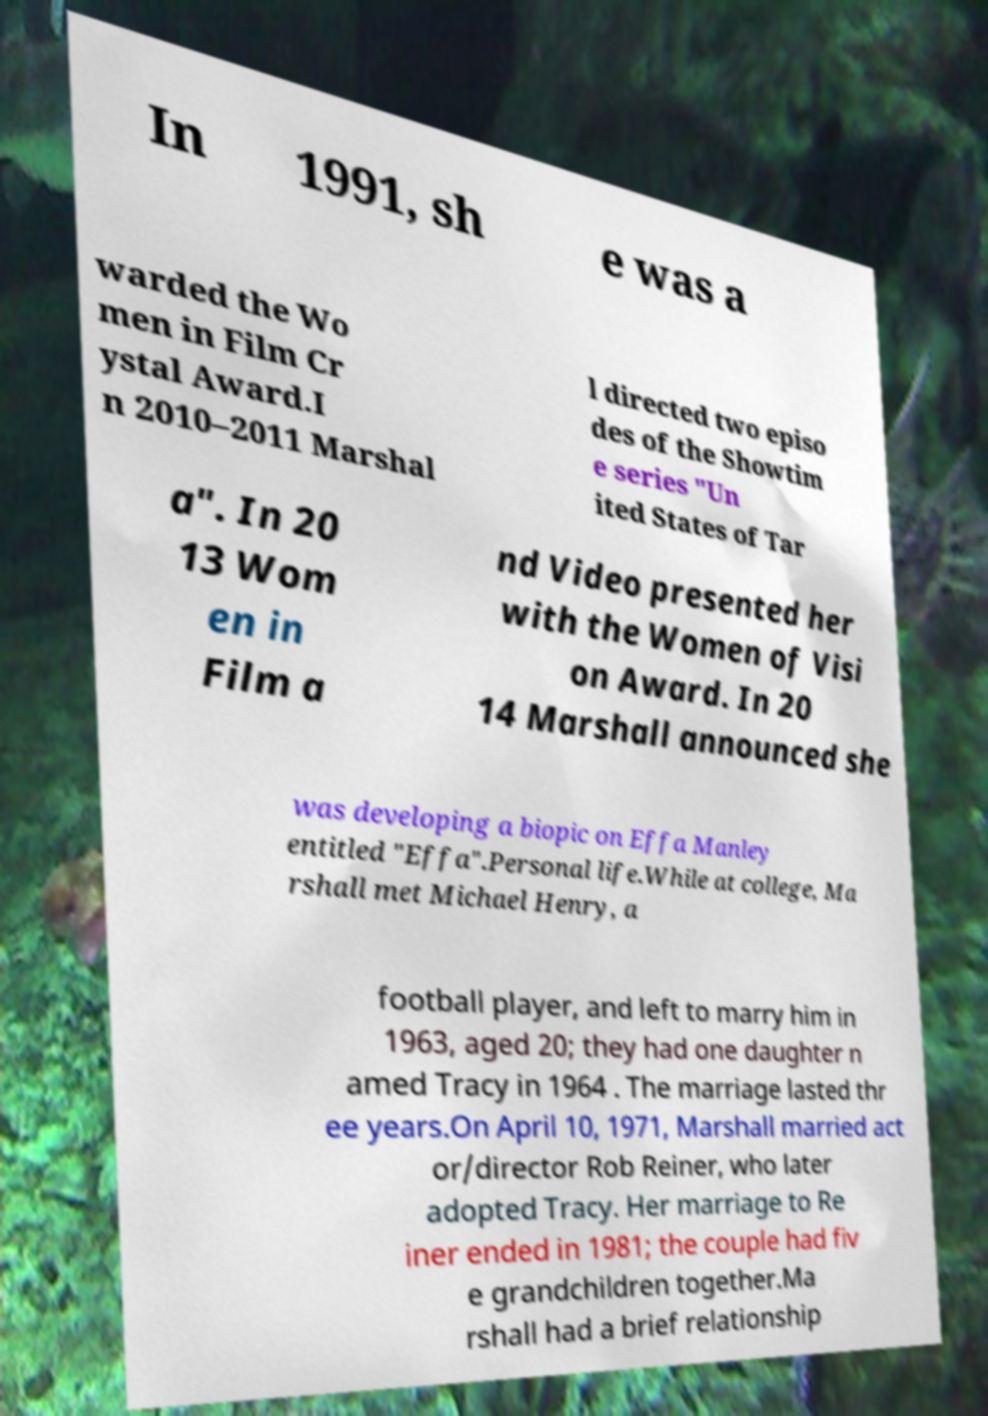There's text embedded in this image that I need extracted. Can you transcribe it verbatim? In 1991, sh e was a warded the Wo men in Film Cr ystal Award.I n 2010–2011 Marshal l directed two episo des of the Showtim e series "Un ited States of Tar a". In 20 13 Wom en in Film a nd Video presented her with the Women of Visi on Award. In 20 14 Marshall announced she was developing a biopic on Effa Manley entitled "Effa".Personal life.While at college, Ma rshall met Michael Henry, a football player, and left to marry him in 1963, aged 20; they had one daughter n amed Tracy in 1964 . The marriage lasted thr ee years.On April 10, 1971, Marshall married act or/director Rob Reiner, who later adopted Tracy. Her marriage to Re iner ended in 1981; the couple had fiv e grandchildren together.Ma rshall had a brief relationship 